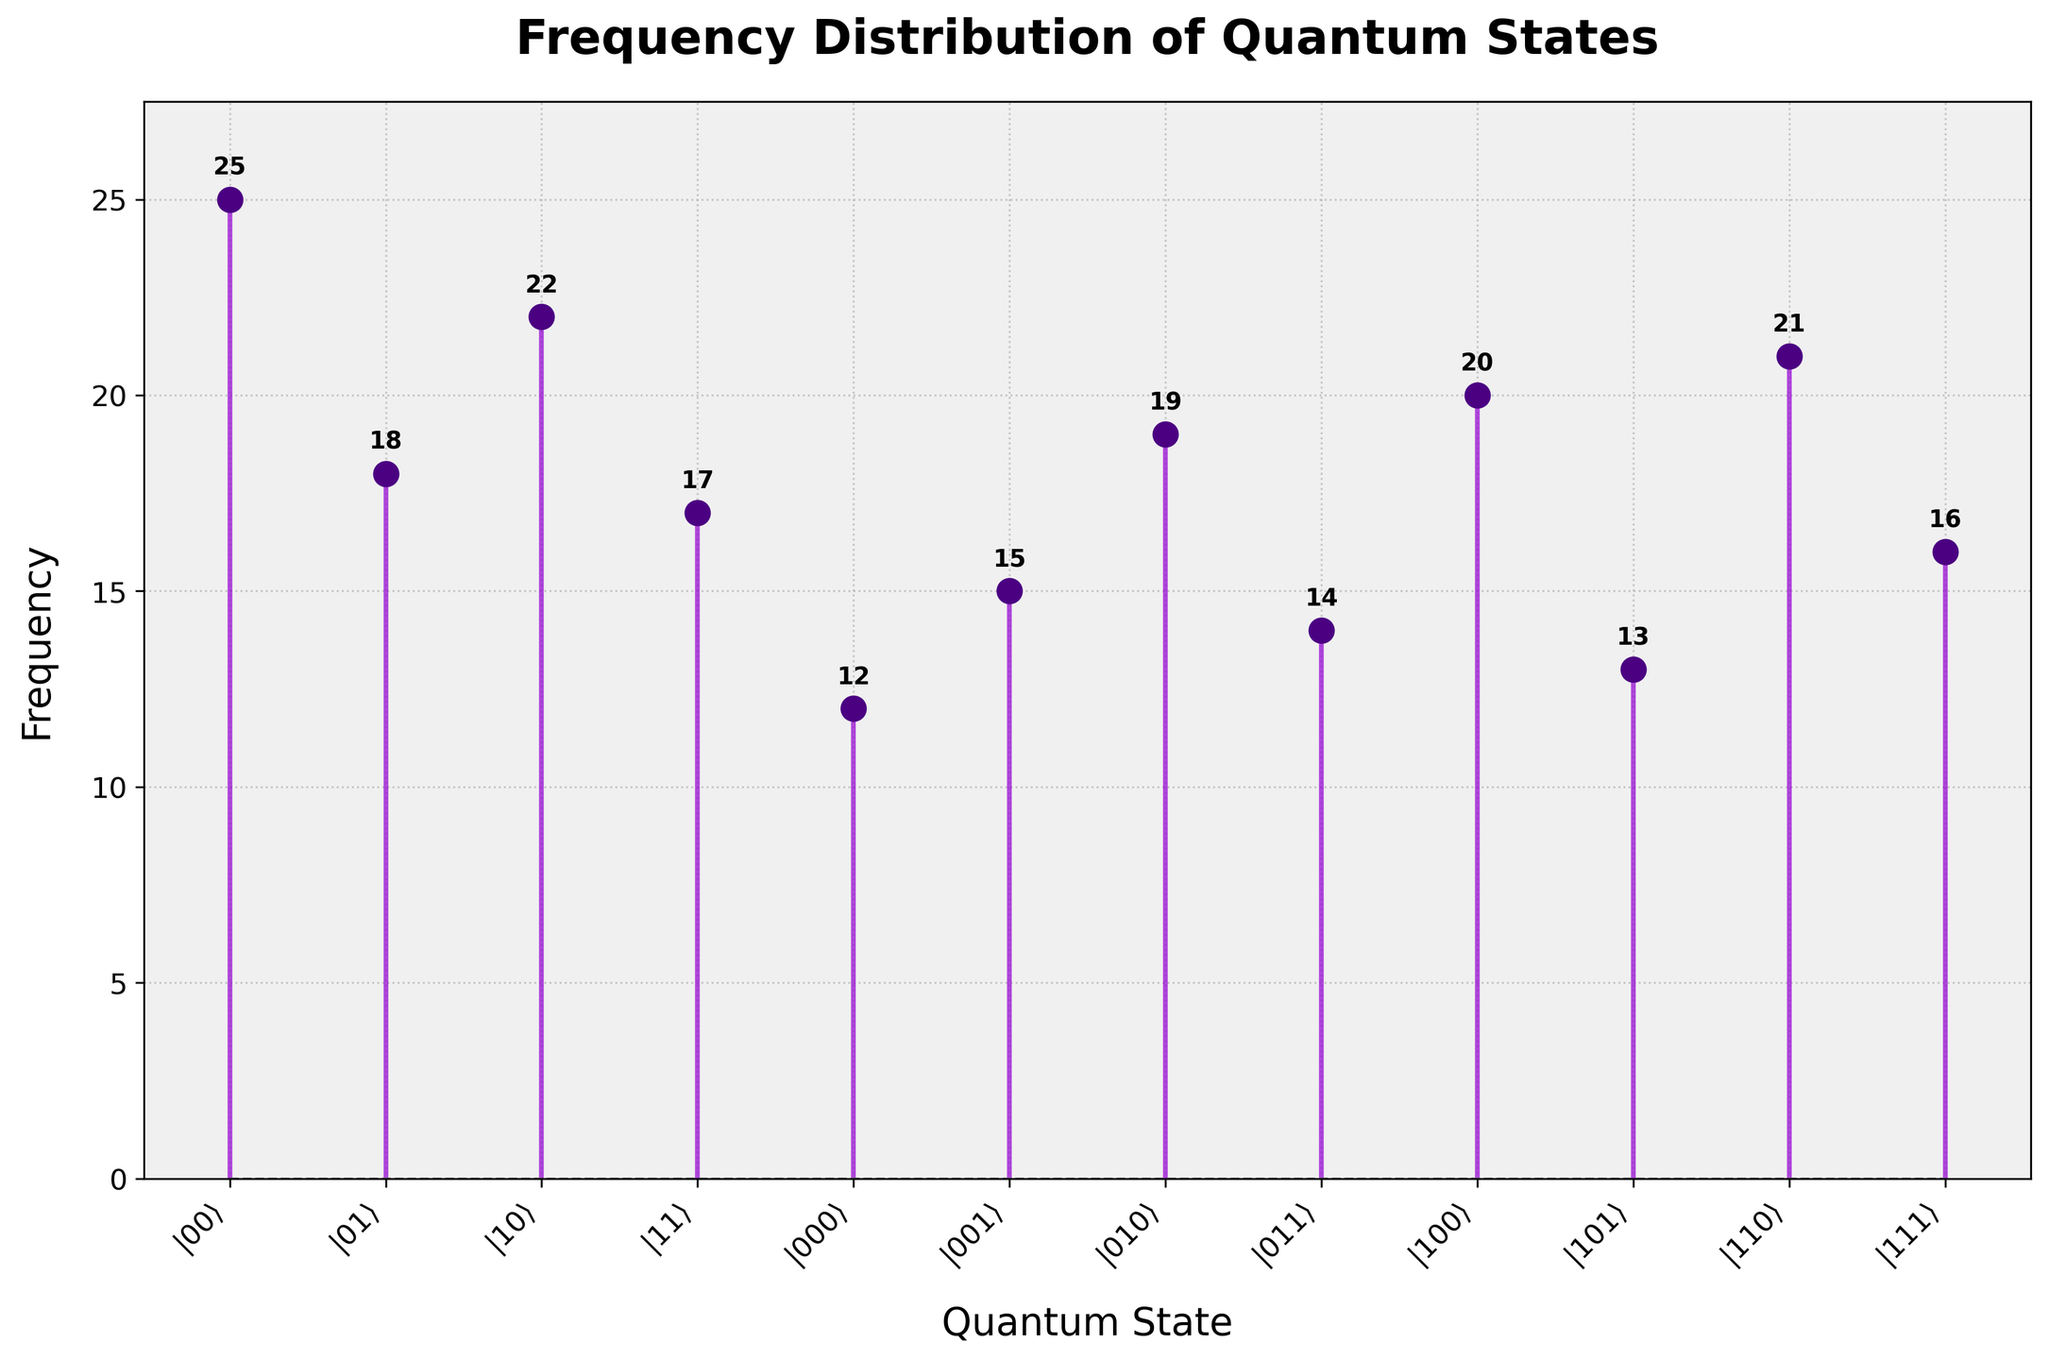What is the title of the plot? The title of the plot is displayed at the top and clearly indicates the subject of the chart.
Answer: Frequency Distribution of Quantum States How many quantum states have a frequency higher than 20? Identify the points on the y-axis that are above 20, and count the corresponding quantum states on the x-axis.
Answer: 2 What is the sum of the frequencies for 3-qubit states only? Add the frequencies for the three-qubit states: (12 + 15 + 19 + 14 + 20 + 13 + 21 + 16) = 130
Answer: 130 What is the overall trend seen in the frequency distribution of quantum states? Examine the pattern in the stem plot to determine if there are any noticeable trends in the distribution of frequencies.
Answer: The frequencies tend to vary without a consistent trend 